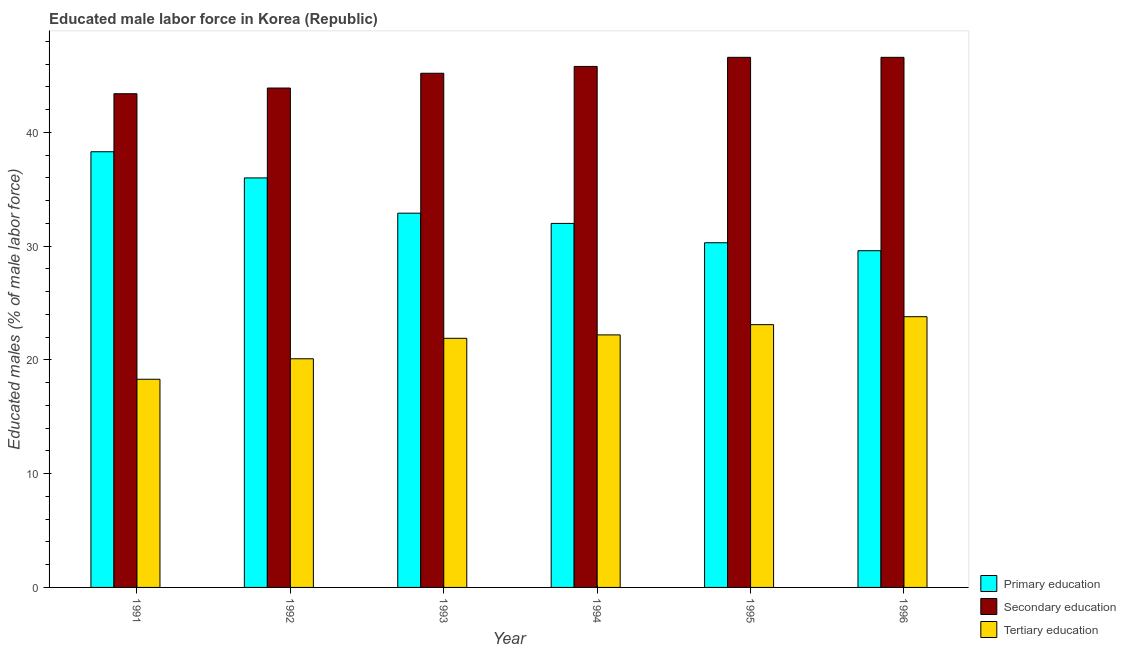How many different coloured bars are there?
Your answer should be very brief. 3. Are the number of bars on each tick of the X-axis equal?
Provide a short and direct response. Yes. How many bars are there on the 5th tick from the left?
Make the answer very short. 3. What is the percentage of male labor force who received secondary education in 1994?
Offer a terse response. 45.8. Across all years, what is the maximum percentage of male labor force who received tertiary education?
Your answer should be very brief. 23.8. Across all years, what is the minimum percentage of male labor force who received tertiary education?
Your answer should be compact. 18.3. What is the total percentage of male labor force who received primary education in the graph?
Your answer should be compact. 199.1. What is the difference between the percentage of male labor force who received tertiary education in 1994 and that in 1995?
Your answer should be very brief. -0.9. What is the difference between the percentage of male labor force who received primary education in 1993 and the percentage of male labor force who received secondary education in 1992?
Offer a terse response. -3.1. What is the average percentage of male labor force who received primary education per year?
Offer a very short reply. 33.18. In the year 1994, what is the difference between the percentage of male labor force who received tertiary education and percentage of male labor force who received primary education?
Make the answer very short. 0. In how many years, is the percentage of male labor force who received tertiary education greater than 14 %?
Give a very brief answer. 6. What is the ratio of the percentage of male labor force who received tertiary education in 1992 to that in 1994?
Offer a terse response. 0.91. What is the difference between the highest and the second highest percentage of male labor force who received primary education?
Keep it short and to the point. 2.3. What is the difference between the highest and the lowest percentage of male labor force who received secondary education?
Ensure brevity in your answer.  3.2. Is the sum of the percentage of male labor force who received primary education in 1991 and 1992 greater than the maximum percentage of male labor force who received secondary education across all years?
Your answer should be compact. Yes. What does the 3rd bar from the left in 1994 represents?
Offer a very short reply. Tertiary education. What does the 3rd bar from the right in 1992 represents?
Give a very brief answer. Primary education. Is it the case that in every year, the sum of the percentage of male labor force who received primary education and percentage of male labor force who received secondary education is greater than the percentage of male labor force who received tertiary education?
Offer a very short reply. Yes. What is the difference between two consecutive major ticks on the Y-axis?
Make the answer very short. 10. Are the values on the major ticks of Y-axis written in scientific E-notation?
Offer a terse response. No. How many legend labels are there?
Ensure brevity in your answer.  3. What is the title of the graph?
Make the answer very short. Educated male labor force in Korea (Republic). What is the label or title of the X-axis?
Give a very brief answer. Year. What is the label or title of the Y-axis?
Your answer should be compact. Educated males (% of male labor force). What is the Educated males (% of male labor force) of Primary education in 1991?
Your answer should be compact. 38.3. What is the Educated males (% of male labor force) in Secondary education in 1991?
Ensure brevity in your answer.  43.4. What is the Educated males (% of male labor force) in Tertiary education in 1991?
Your response must be concise. 18.3. What is the Educated males (% of male labor force) in Secondary education in 1992?
Provide a short and direct response. 43.9. What is the Educated males (% of male labor force) of Tertiary education in 1992?
Offer a very short reply. 20.1. What is the Educated males (% of male labor force) of Primary education in 1993?
Offer a very short reply. 32.9. What is the Educated males (% of male labor force) of Secondary education in 1993?
Make the answer very short. 45.2. What is the Educated males (% of male labor force) in Tertiary education in 1993?
Provide a succinct answer. 21.9. What is the Educated males (% of male labor force) of Primary education in 1994?
Offer a terse response. 32. What is the Educated males (% of male labor force) of Secondary education in 1994?
Keep it short and to the point. 45.8. What is the Educated males (% of male labor force) of Tertiary education in 1994?
Your answer should be compact. 22.2. What is the Educated males (% of male labor force) of Primary education in 1995?
Offer a terse response. 30.3. What is the Educated males (% of male labor force) of Secondary education in 1995?
Offer a very short reply. 46.6. What is the Educated males (% of male labor force) of Tertiary education in 1995?
Give a very brief answer. 23.1. What is the Educated males (% of male labor force) of Primary education in 1996?
Your answer should be very brief. 29.6. What is the Educated males (% of male labor force) in Secondary education in 1996?
Offer a very short reply. 46.6. What is the Educated males (% of male labor force) in Tertiary education in 1996?
Your answer should be compact. 23.8. Across all years, what is the maximum Educated males (% of male labor force) of Primary education?
Give a very brief answer. 38.3. Across all years, what is the maximum Educated males (% of male labor force) of Secondary education?
Offer a terse response. 46.6. Across all years, what is the maximum Educated males (% of male labor force) in Tertiary education?
Provide a succinct answer. 23.8. Across all years, what is the minimum Educated males (% of male labor force) of Primary education?
Give a very brief answer. 29.6. Across all years, what is the minimum Educated males (% of male labor force) in Secondary education?
Your response must be concise. 43.4. Across all years, what is the minimum Educated males (% of male labor force) of Tertiary education?
Provide a short and direct response. 18.3. What is the total Educated males (% of male labor force) of Primary education in the graph?
Your answer should be compact. 199.1. What is the total Educated males (% of male labor force) of Secondary education in the graph?
Your response must be concise. 271.5. What is the total Educated males (% of male labor force) in Tertiary education in the graph?
Provide a succinct answer. 129.4. What is the difference between the Educated males (% of male labor force) of Primary education in 1991 and that in 1992?
Your answer should be very brief. 2.3. What is the difference between the Educated males (% of male labor force) in Tertiary education in 1991 and that in 1992?
Keep it short and to the point. -1.8. What is the difference between the Educated males (% of male labor force) in Primary education in 1991 and that in 1994?
Make the answer very short. 6.3. What is the difference between the Educated males (% of male labor force) in Tertiary education in 1991 and that in 1994?
Provide a succinct answer. -3.9. What is the difference between the Educated males (% of male labor force) of Primary education in 1991 and that in 1995?
Make the answer very short. 8. What is the difference between the Educated males (% of male labor force) of Secondary education in 1991 and that in 1995?
Offer a terse response. -3.2. What is the difference between the Educated males (% of male labor force) in Tertiary education in 1991 and that in 1995?
Give a very brief answer. -4.8. What is the difference between the Educated males (% of male labor force) in Secondary education in 1991 and that in 1996?
Offer a terse response. -3.2. What is the difference between the Educated males (% of male labor force) in Tertiary education in 1991 and that in 1996?
Your response must be concise. -5.5. What is the difference between the Educated males (% of male labor force) in Primary education in 1992 and that in 1993?
Offer a very short reply. 3.1. What is the difference between the Educated males (% of male labor force) of Secondary education in 1992 and that in 1993?
Your response must be concise. -1.3. What is the difference between the Educated males (% of male labor force) in Tertiary education in 1992 and that in 1993?
Ensure brevity in your answer.  -1.8. What is the difference between the Educated males (% of male labor force) of Primary education in 1992 and that in 1994?
Keep it short and to the point. 4. What is the difference between the Educated males (% of male labor force) in Secondary education in 1992 and that in 1994?
Your response must be concise. -1.9. What is the difference between the Educated males (% of male labor force) of Tertiary education in 1992 and that in 1995?
Your answer should be compact. -3. What is the difference between the Educated males (% of male labor force) in Primary education in 1992 and that in 1996?
Offer a very short reply. 6.4. What is the difference between the Educated males (% of male labor force) of Tertiary education in 1993 and that in 1994?
Ensure brevity in your answer.  -0.3. What is the difference between the Educated males (% of male labor force) of Primary education in 1993 and that in 1995?
Offer a terse response. 2.6. What is the difference between the Educated males (% of male labor force) in Secondary education in 1993 and that in 1995?
Provide a short and direct response. -1.4. What is the difference between the Educated males (% of male labor force) of Primary education in 1994 and that in 1995?
Offer a very short reply. 1.7. What is the difference between the Educated males (% of male labor force) in Primary education in 1994 and that in 1996?
Your response must be concise. 2.4. What is the difference between the Educated males (% of male labor force) of Tertiary education in 1994 and that in 1996?
Give a very brief answer. -1.6. What is the difference between the Educated males (% of male labor force) of Tertiary education in 1995 and that in 1996?
Offer a very short reply. -0.7. What is the difference between the Educated males (% of male labor force) in Primary education in 1991 and the Educated males (% of male labor force) in Tertiary education in 1992?
Ensure brevity in your answer.  18.2. What is the difference between the Educated males (% of male labor force) in Secondary education in 1991 and the Educated males (% of male labor force) in Tertiary education in 1992?
Give a very brief answer. 23.3. What is the difference between the Educated males (% of male labor force) in Primary education in 1991 and the Educated males (% of male labor force) in Secondary education in 1993?
Give a very brief answer. -6.9. What is the difference between the Educated males (% of male labor force) of Primary education in 1991 and the Educated males (% of male labor force) of Tertiary education in 1993?
Your response must be concise. 16.4. What is the difference between the Educated males (% of male labor force) of Primary education in 1991 and the Educated males (% of male labor force) of Secondary education in 1994?
Offer a very short reply. -7.5. What is the difference between the Educated males (% of male labor force) of Primary education in 1991 and the Educated males (% of male labor force) of Tertiary education in 1994?
Provide a succinct answer. 16.1. What is the difference between the Educated males (% of male labor force) in Secondary education in 1991 and the Educated males (% of male labor force) in Tertiary education in 1994?
Ensure brevity in your answer.  21.2. What is the difference between the Educated males (% of male labor force) in Secondary education in 1991 and the Educated males (% of male labor force) in Tertiary education in 1995?
Keep it short and to the point. 20.3. What is the difference between the Educated males (% of male labor force) of Primary education in 1991 and the Educated males (% of male labor force) of Secondary education in 1996?
Your answer should be compact. -8.3. What is the difference between the Educated males (% of male labor force) in Primary education in 1991 and the Educated males (% of male labor force) in Tertiary education in 1996?
Your answer should be very brief. 14.5. What is the difference between the Educated males (% of male labor force) of Secondary education in 1991 and the Educated males (% of male labor force) of Tertiary education in 1996?
Ensure brevity in your answer.  19.6. What is the difference between the Educated males (% of male labor force) in Secondary education in 1992 and the Educated males (% of male labor force) in Tertiary education in 1993?
Your answer should be very brief. 22. What is the difference between the Educated males (% of male labor force) in Primary education in 1992 and the Educated males (% of male labor force) in Tertiary education in 1994?
Provide a succinct answer. 13.8. What is the difference between the Educated males (% of male labor force) in Secondary education in 1992 and the Educated males (% of male labor force) in Tertiary education in 1994?
Provide a succinct answer. 21.7. What is the difference between the Educated males (% of male labor force) of Secondary education in 1992 and the Educated males (% of male labor force) of Tertiary education in 1995?
Provide a succinct answer. 20.8. What is the difference between the Educated males (% of male labor force) of Primary education in 1992 and the Educated males (% of male labor force) of Secondary education in 1996?
Your response must be concise. -10.6. What is the difference between the Educated males (% of male labor force) of Primary education in 1992 and the Educated males (% of male labor force) of Tertiary education in 1996?
Offer a very short reply. 12.2. What is the difference between the Educated males (% of male labor force) in Secondary education in 1992 and the Educated males (% of male labor force) in Tertiary education in 1996?
Provide a short and direct response. 20.1. What is the difference between the Educated males (% of male labor force) of Primary education in 1993 and the Educated males (% of male labor force) of Tertiary education in 1994?
Make the answer very short. 10.7. What is the difference between the Educated males (% of male labor force) of Secondary education in 1993 and the Educated males (% of male labor force) of Tertiary education in 1994?
Make the answer very short. 23. What is the difference between the Educated males (% of male labor force) of Primary education in 1993 and the Educated males (% of male labor force) of Secondary education in 1995?
Make the answer very short. -13.7. What is the difference between the Educated males (% of male labor force) of Primary education in 1993 and the Educated males (% of male labor force) of Tertiary education in 1995?
Ensure brevity in your answer.  9.8. What is the difference between the Educated males (% of male labor force) in Secondary education in 1993 and the Educated males (% of male labor force) in Tertiary education in 1995?
Provide a short and direct response. 22.1. What is the difference between the Educated males (% of male labor force) of Primary education in 1993 and the Educated males (% of male labor force) of Secondary education in 1996?
Your answer should be compact. -13.7. What is the difference between the Educated males (% of male labor force) of Primary education in 1993 and the Educated males (% of male labor force) of Tertiary education in 1996?
Give a very brief answer. 9.1. What is the difference between the Educated males (% of male labor force) in Secondary education in 1993 and the Educated males (% of male labor force) in Tertiary education in 1996?
Offer a terse response. 21.4. What is the difference between the Educated males (% of male labor force) of Primary education in 1994 and the Educated males (% of male labor force) of Secondary education in 1995?
Your response must be concise. -14.6. What is the difference between the Educated males (% of male labor force) in Primary education in 1994 and the Educated males (% of male labor force) in Tertiary education in 1995?
Your response must be concise. 8.9. What is the difference between the Educated males (% of male labor force) in Secondary education in 1994 and the Educated males (% of male labor force) in Tertiary education in 1995?
Provide a short and direct response. 22.7. What is the difference between the Educated males (% of male labor force) of Primary education in 1994 and the Educated males (% of male labor force) of Secondary education in 1996?
Offer a terse response. -14.6. What is the difference between the Educated males (% of male labor force) of Primary education in 1995 and the Educated males (% of male labor force) of Secondary education in 1996?
Offer a very short reply. -16.3. What is the difference between the Educated males (% of male labor force) of Primary education in 1995 and the Educated males (% of male labor force) of Tertiary education in 1996?
Your response must be concise. 6.5. What is the difference between the Educated males (% of male labor force) of Secondary education in 1995 and the Educated males (% of male labor force) of Tertiary education in 1996?
Your answer should be very brief. 22.8. What is the average Educated males (% of male labor force) of Primary education per year?
Your response must be concise. 33.18. What is the average Educated males (% of male labor force) in Secondary education per year?
Provide a succinct answer. 45.25. What is the average Educated males (% of male labor force) in Tertiary education per year?
Provide a succinct answer. 21.57. In the year 1991, what is the difference between the Educated males (% of male labor force) of Primary education and Educated males (% of male labor force) of Secondary education?
Make the answer very short. -5.1. In the year 1991, what is the difference between the Educated males (% of male labor force) in Primary education and Educated males (% of male labor force) in Tertiary education?
Your answer should be very brief. 20. In the year 1991, what is the difference between the Educated males (% of male labor force) of Secondary education and Educated males (% of male labor force) of Tertiary education?
Your answer should be very brief. 25.1. In the year 1992, what is the difference between the Educated males (% of male labor force) in Secondary education and Educated males (% of male labor force) in Tertiary education?
Offer a very short reply. 23.8. In the year 1993, what is the difference between the Educated males (% of male labor force) in Secondary education and Educated males (% of male labor force) in Tertiary education?
Provide a short and direct response. 23.3. In the year 1994, what is the difference between the Educated males (% of male labor force) in Primary education and Educated males (% of male labor force) in Secondary education?
Ensure brevity in your answer.  -13.8. In the year 1994, what is the difference between the Educated males (% of male labor force) in Secondary education and Educated males (% of male labor force) in Tertiary education?
Make the answer very short. 23.6. In the year 1995, what is the difference between the Educated males (% of male labor force) of Primary education and Educated males (% of male labor force) of Secondary education?
Your response must be concise. -16.3. In the year 1995, what is the difference between the Educated males (% of male labor force) of Secondary education and Educated males (% of male labor force) of Tertiary education?
Your response must be concise. 23.5. In the year 1996, what is the difference between the Educated males (% of male labor force) in Primary education and Educated males (% of male labor force) in Tertiary education?
Your answer should be very brief. 5.8. In the year 1996, what is the difference between the Educated males (% of male labor force) in Secondary education and Educated males (% of male labor force) in Tertiary education?
Your answer should be compact. 22.8. What is the ratio of the Educated males (% of male labor force) in Primary education in 1991 to that in 1992?
Your answer should be very brief. 1.06. What is the ratio of the Educated males (% of male labor force) of Tertiary education in 1991 to that in 1992?
Offer a very short reply. 0.91. What is the ratio of the Educated males (% of male labor force) in Primary education in 1991 to that in 1993?
Ensure brevity in your answer.  1.16. What is the ratio of the Educated males (% of male labor force) in Secondary education in 1991 to that in 1993?
Keep it short and to the point. 0.96. What is the ratio of the Educated males (% of male labor force) in Tertiary education in 1991 to that in 1993?
Offer a terse response. 0.84. What is the ratio of the Educated males (% of male labor force) of Primary education in 1991 to that in 1994?
Provide a succinct answer. 1.2. What is the ratio of the Educated males (% of male labor force) in Secondary education in 1991 to that in 1994?
Your response must be concise. 0.95. What is the ratio of the Educated males (% of male labor force) of Tertiary education in 1991 to that in 1994?
Offer a very short reply. 0.82. What is the ratio of the Educated males (% of male labor force) in Primary education in 1991 to that in 1995?
Give a very brief answer. 1.26. What is the ratio of the Educated males (% of male labor force) of Secondary education in 1991 to that in 1995?
Ensure brevity in your answer.  0.93. What is the ratio of the Educated males (% of male labor force) in Tertiary education in 1991 to that in 1995?
Make the answer very short. 0.79. What is the ratio of the Educated males (% of male labor force) of Primary education in 1991 to that in 1996?
Provide a short and direct response. 1.29. What is the ratio of the Educated males (% of male labor force) in Secondary education in 1991 to that in 1996?
Provide a succinct answer. 0.93. What is the ratio of the Educated males (% of male labor force) in Tertiary education in 1991 to that in 1996?
Your answer should be very brief. 0.77. What is the ratio of the Educated males (% of male labor force) of Primary education in 1992 to that in 1993?
Offer a terse response. 1.09. What is the ratio of the Educated males (% of male labor force) in Secondary education in 1992 to that in 1993?
Your answer should be very brief. 0.97. What is the ratio of the Educated males (% of male labor force) of Tertiary education in 1992 to that in 1993?
Offer a very short reply. 0.92. What is the ratio of the Educated males (% of male labor force) of Secondary education in 1992 to that in 1994?
Offer a terse response. 0.96. What is the ratio of the Educated males (% of male labor force) in Tertiary education in 1992 to that in 1994?
Offer a terse response. 0.91. What is the ratio of the Educated males (% of male labor force) in Primary education in 1992 to that in 1995?
Give a very brief answer. 1.19. What is the ratio of the Educated males (% of male labor force) in Secondary education in 1992 to that in 1995?
Offer a terse response. 0.94. What is the ratio of the Educated males (% of male labor force) of Tertiary education in 1992 to that in 1995?
Offer a very short reply. 0.87. What is the ratio of the Educated males (% of male labor force) of Primary education in 1992 to that in 1996?
Your answer should be very brief. 1.22. What is the ratio of the Educated males (% of male labor force) in Secondary education in 1992 to that in 1996?
Your answer should be very brief. 0.94. What is the ratio of the Educated males (% of male labor force) of Tertiary education in 1992 to that in 1996?
Offer a terse response. 0.84. What is the ratio of the Educated males (% of male labor force) in Primary education in 1993 to that in 1994?
Make the answer very short. 1.03. What is the ratio of the Educated males (% of male labor force) of Secondary education in 1993 to that in 1994?
Keep it short and to the point. 0.99. What is the ratio of the Educated males (% of male labor force) of Tertiary education in 1993 to that in 1994?
Offer a terse response. 0.99. What is the ratio of the Educated males (% of male labor force) in Primary education in 1993 to that in 1995?
Your response must be concise. 1.09. What is the ratio of the Educated males (% of male labor force) in Secondary education in 1993 to that in 1995?
Make the answer very short. 0.97. What is the ratio of the Educated males (% of male labor force) of Tertiary education in 1993 to that in 1995?
Make the answer very short. 0.95. What is the ratio of the Educated males (% of male labor force) of Primary education in 1993 to that in 1996?
Your answer should be compact. 1.11. What is the ratio of the Educated males (% of male labor force) in Tertiary education in 1993 to that in 1996?
Ensure brevity in your answer.  0.92. What is the ratio of the Educated males (% of male labor force) of Primary education in 1994 to that in 1995?
Give a very brief answer. 1.06. What is the ratio of the Educated males (% of male labor force) of Secondary education in 1994 to that in 1995?
Ensure brevity in your answer.  0.98. What is the ratio of the Educated males (% of male labor force) of Tertiary education in 1994 to that in 1995?
Make the answer very short. 0.96. What is the ratio of the Educated males (% of male labor force) of Primary education in 1994 to that in 1996?
Your answer should be very brief. 1.08. What is the ratio of the Educated males (% of male labor force) of Secondary education in 1994 to that in 1996?
Offer a very short reply. 0.98. What is the ratio of the Educated males (% of male labor force) in Tertiary education in 1994 to that in 1996?
Ensure brevity in your answer.  0.93. What is the ratio of the Educated males (% of male labor force) of Primary education in 1995 to that in 1996?
Offer a very short reply. 1.02. What is the ratio of the Educated males (% of male labor force) of Secondary education in 1995 to that in 1996?
Keep it short and to the point. 1. What is the ratio of the Educated males (% of male labor force) of Tertiary education in 1995 to that in 1996?
Provide a short and direct response. 0.97. What is the difference between the highest and the second highest Educated males (% of male labor force) in Secondary education?
Give a very brief answer. 0. What is the difference between the highest and the lowest Educated males (% of male labor force) in Primary education?
Offer a very short reply. 8.7. What is the difference between the highest and the lowest Educated males (% of male labor force) in Secondary education?
Offer a terse response. 3.2. 